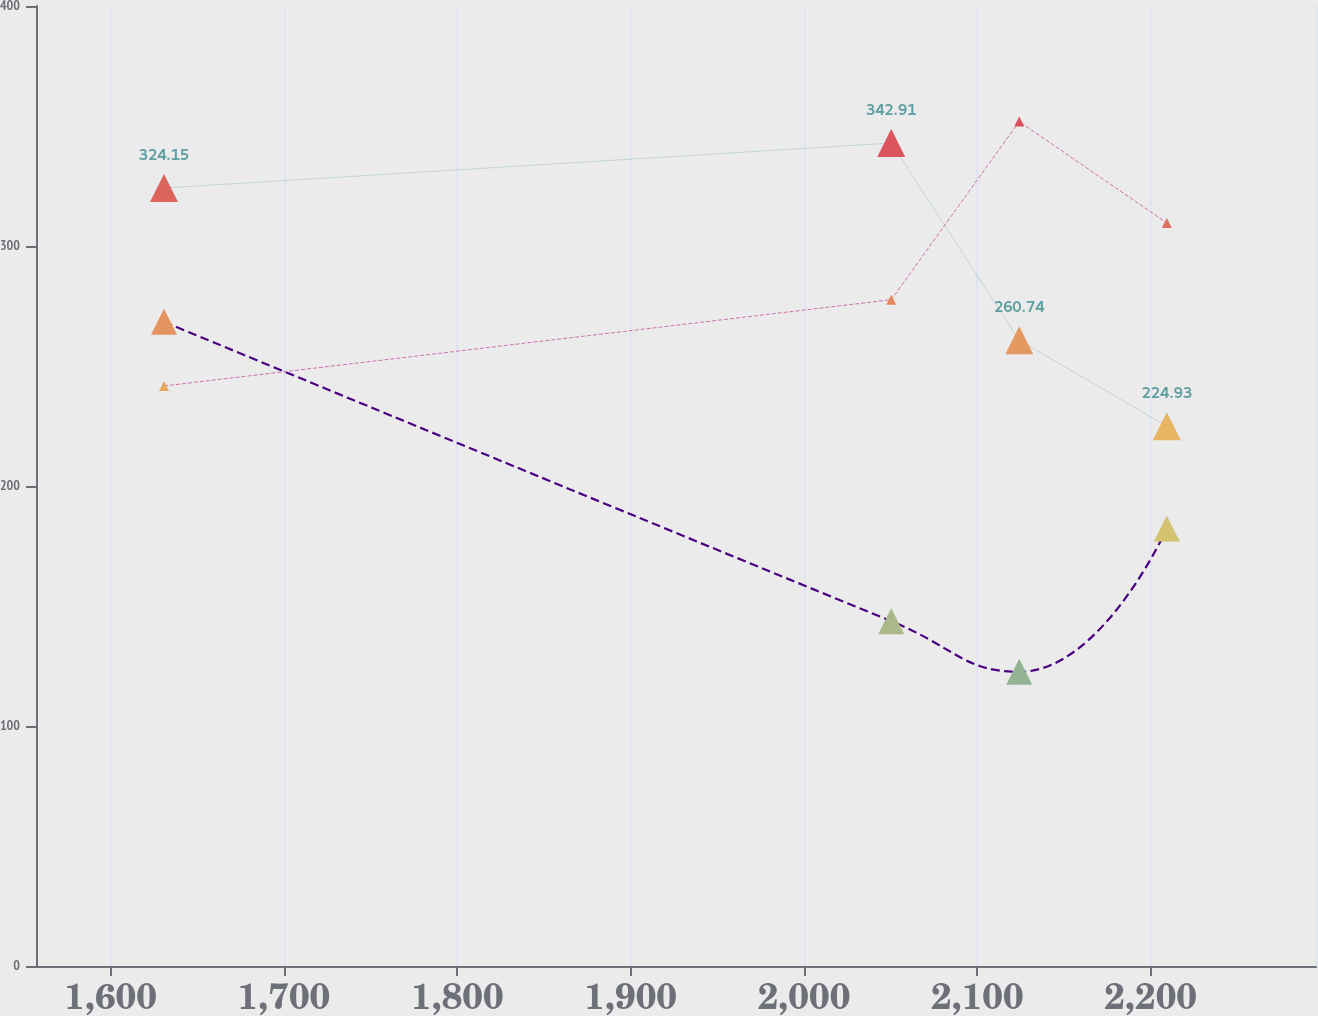Convert chart. <chart><loc_0><loc_0><loc_500><loc_500><line_chart><ecel><fcel>Operating Lease Equipment Payments Receivable<fcel>Principal Payments on Notes Receivable<fcel>Sales- Type/ Finance Lease Payments Receivable<nl><fcel>1630.8<fcel>268.39<fcel>241.68<fcel>324.15<nl><fcel>2050.32<fcel>143.69<fcel>277.61<fcel>342.91<nl><fcel>2124.16<fcel>122.56<fcel>351.86<fcel>260.74<nl><fcel>2209.31<fcel>182.33<fcel>309.6<fcel>224.93<nl><fcel>2369.2<fcel>57.05<fcel>266.59<fcel>138.88<nl></chart> 